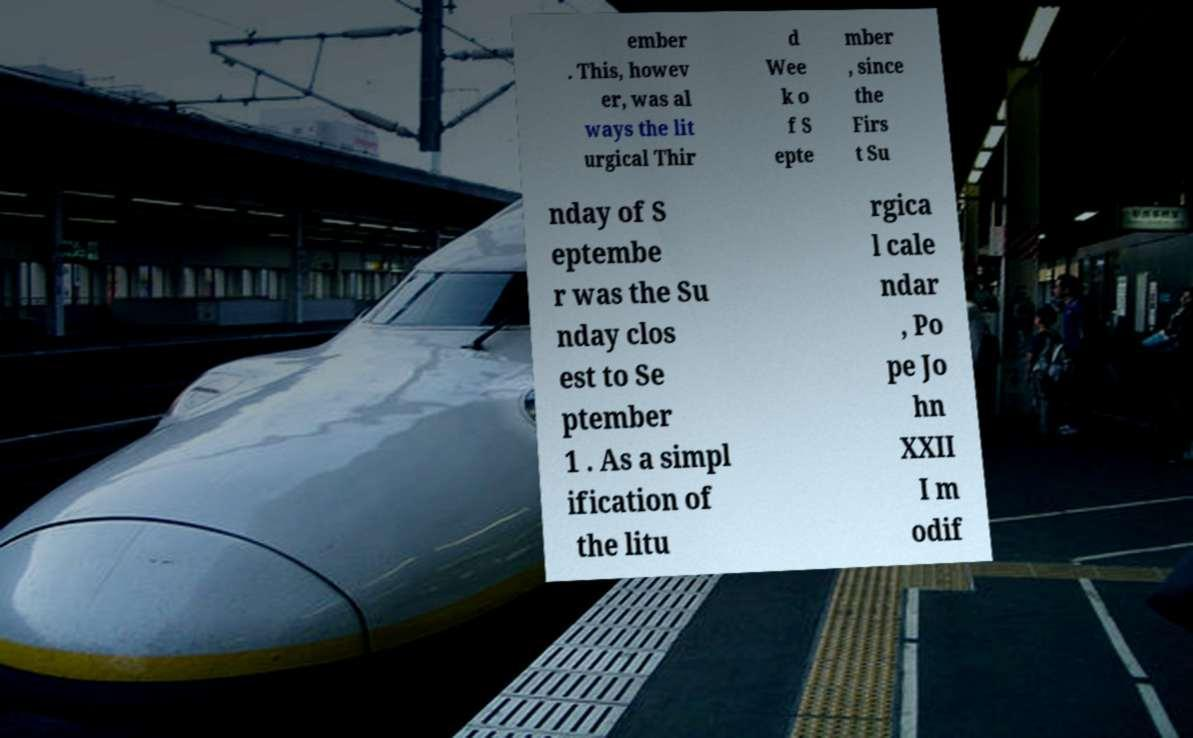Please identify and transcribe the text found in this image. ember . This, howev er, was al ways the lit urgical Thir d Wee k o f S epte mber , since the Firs t Su nday of S eptembe r was the Su nday clos est to Se ptember 1 . As a simpl ification of the litu rgica l cale ndar , Po pe Jo hn XXII I m odif 